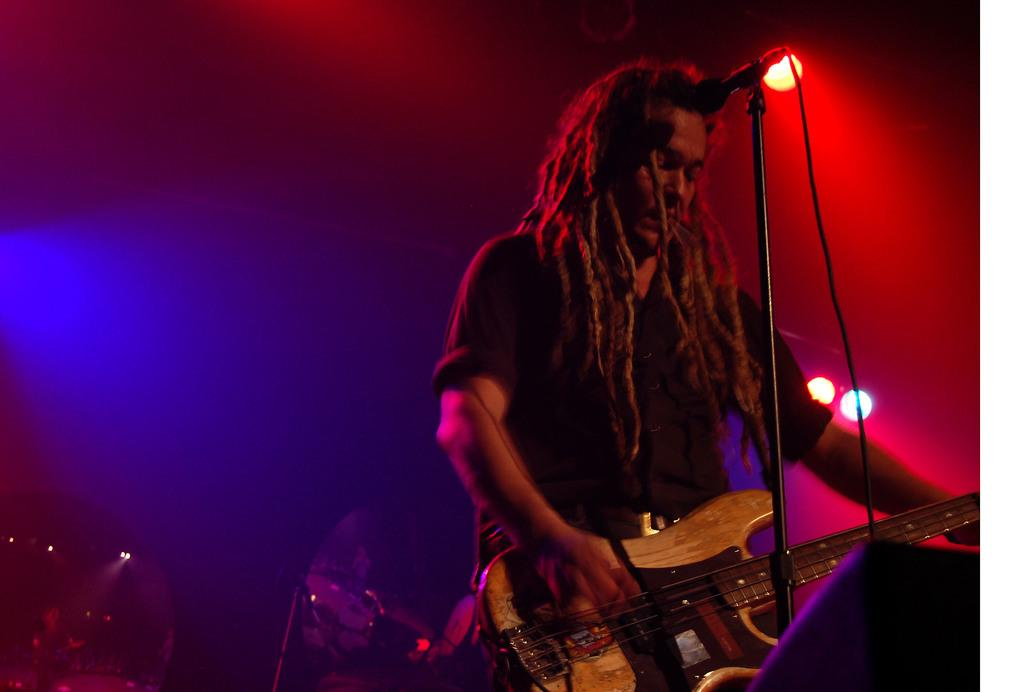Who is present in the image? There is a man in the image. What is the man doing in the image? The man is standing in the image. What object is the man holding in his hands? The man is holding a guitar in his hands. What equipment is present for amplifying sound in the image? There is a microphone and a microphone stand in the image. What can be seen in the image that might provide illumination? There are lights visible in the image. How does the wind affect the man's performance in the image? There is no mention of wind in the image, so its effect on the man's performance cannot be determined. What process is the man following to create the music in the image? The image does not provide enough information to determine the specific process the man is using to create music. 